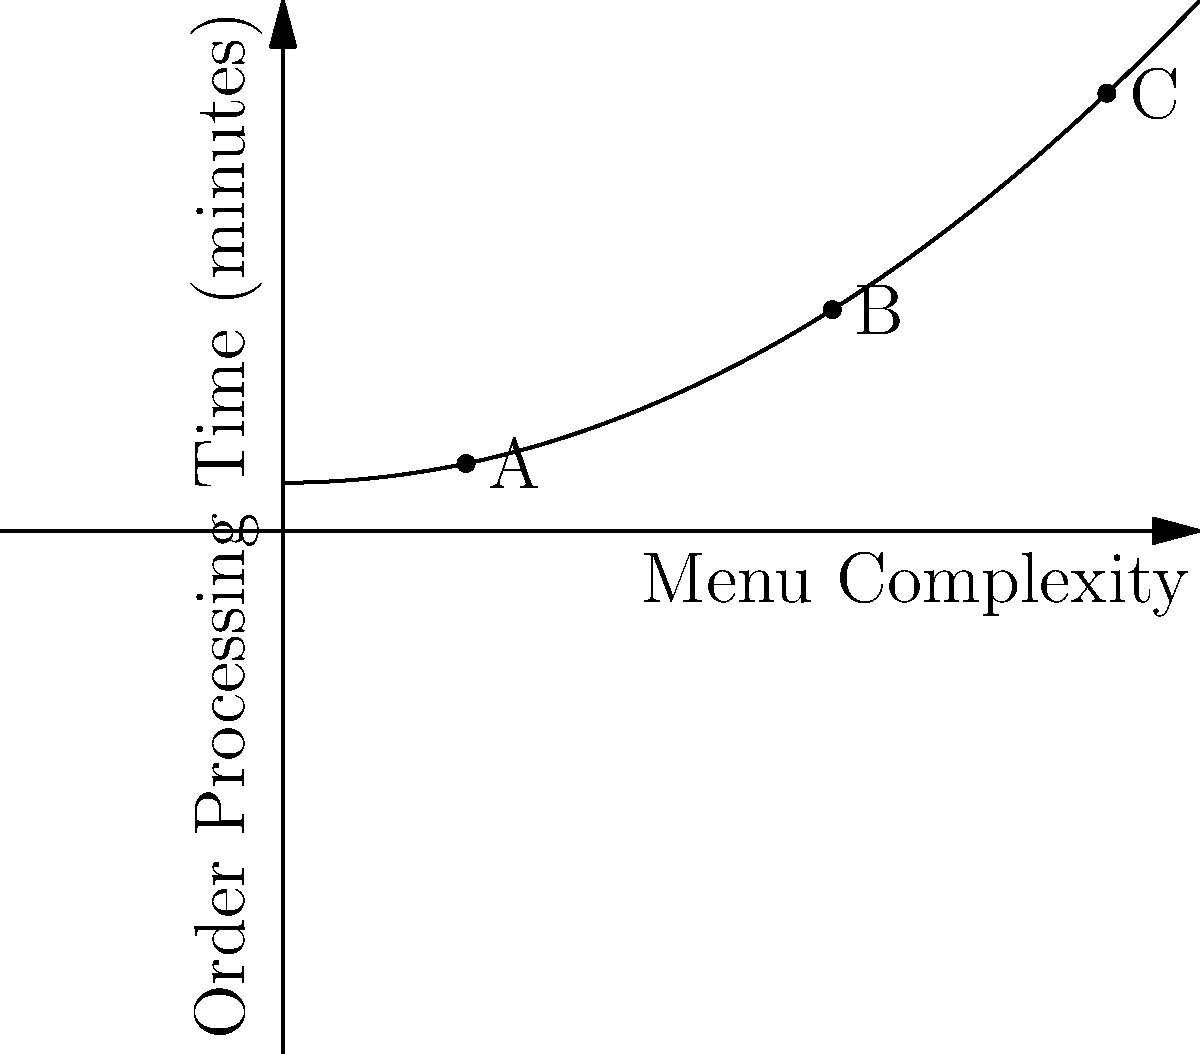As a mobile app developer for food truck ordering systems, you've collected data on menu complexity and order processing times. The graph shows the relationship between these variables. If a food truck owner wants to reduce their average order processing time from point C to point B, by approximately what percentage should they reduce their menu complexity? To solve this problem, we need to follow these steps:

1. Identify the x-coordinates (menu complexity) for points B and C:
   Point B: x ≈ 6
   Point C: x ≈ 9

2. Calculate the difference in menu complexity:
   Difference = 9 - 6 = 3

3. Calculate the percentage reduction:
   Percentage reduction = (Difference / Original Value) * 100
   = (3 / 9) * 100
   ≈ 33.33%

4. Round to the nearest whole percentage:
   33%

The food truck owner should reduce their menu complexity by approximately 33% to move from point C to point B, which would result in a lower average order processing time.
Answer: 33% 